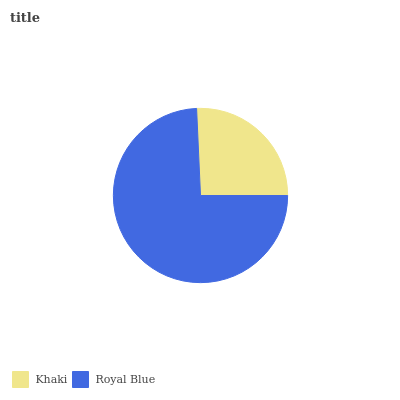Is Khaki the minimum?
Answer yes or no. Yes. Is Royal Blue the maximum?
Answer yes or no. Yes. Is Royal Blue the minimum?
Answer yes or no. No. Is Royal Blue greater than Khaki?
Answer yes or no. Yes. Is Khaki less than Royal Blue?
Answer yes or no. Yes. Is Khaki greater than Royal Blue?
Answer yes or no. No. Is Royal Blue less than Khaki?
Answer yes or no. No. Is Royal Blue the high median?
Answer yes or no. Yes. Is Khaki the low median?
Answer yes or no. Yes. Is Khaki the high median?
Answer yes or no. No. Is Royal Blue the low median?
Answer yes or no. No. 